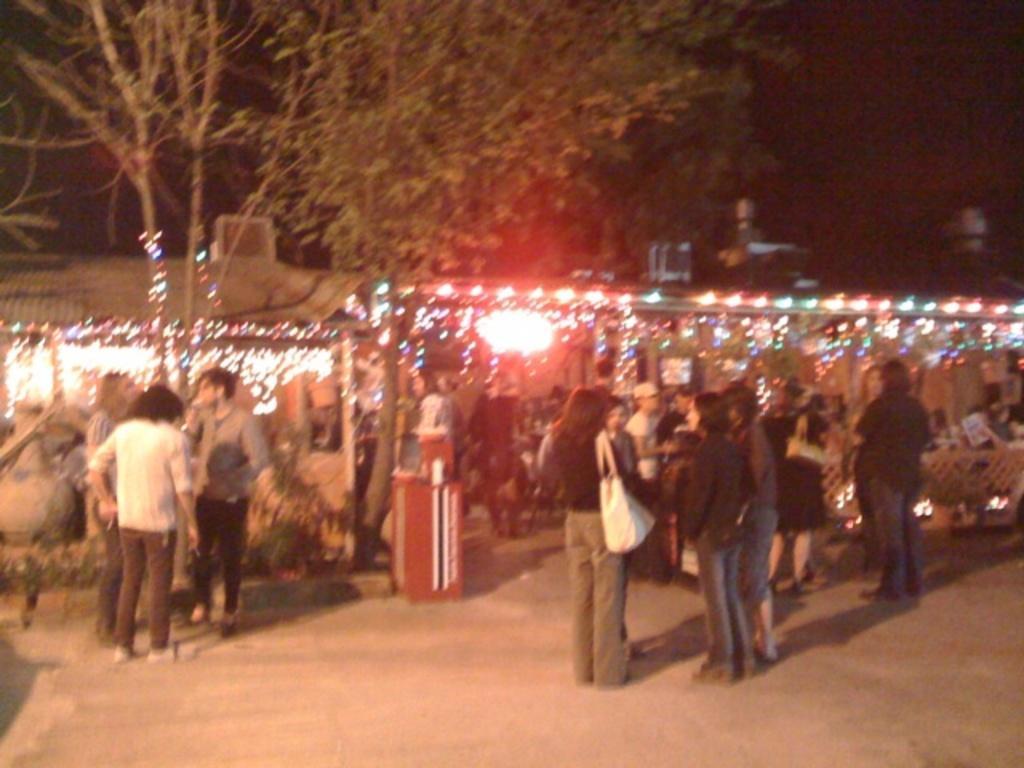How would you summarize this image in a sentence or two? In this image I can see number of people are standing and in the front I can see one of them is carrying a bag. In the background I can see few buildings and on it I can see number of lights as decoration. I can also see few trees on the left side and I can see this image is little bit blurry. 